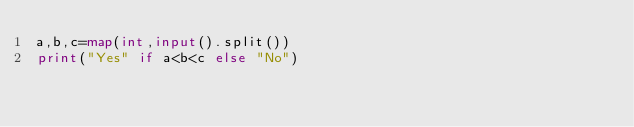Convert code to text. <code><loc_0><loc_0><loc_500><loc_500><_Python_>a,b,c=map(int,input().split())
print("Yes" if a<b<c else "No")
</code> 